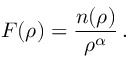<formula> <loc_0><loc_0><loc_500><loc_500>F ( \rho ) = \frac { n ( \rho ) } { \rho ^ { \alpha } } \, .</formula> 